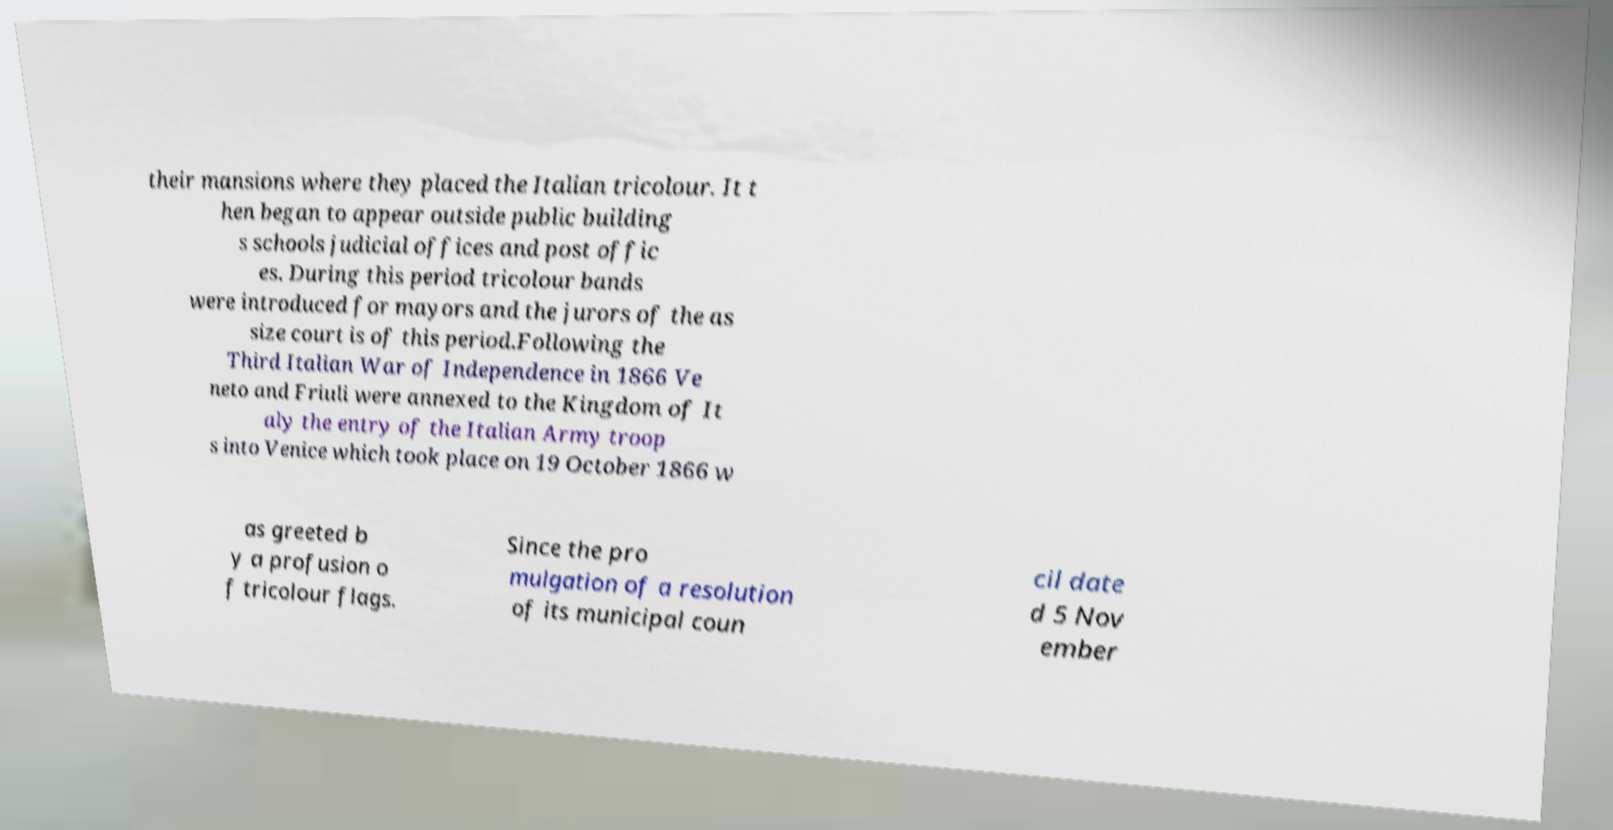Could you assist in decoding the text presented in this image and type it out clearly? their mansions where they placed the Italian tricolour. It t hen began to appear outside public building s schools judicial offices and post offic es. During this period tricolour bands were introduced for mayors and the jurors of the as size court is of this period.Following the Third Italian War of Independence in 1866 Ve neto and Friuli were annexed to the Kingdom of It aly the entry of the Italian Army troop s into Venice which took place on 19 October 1866 w as greeted b y a profusion o f tricolour flags. Since the pro mulgation of a resolution of its municipal coun cil date d 5 Nov ember 